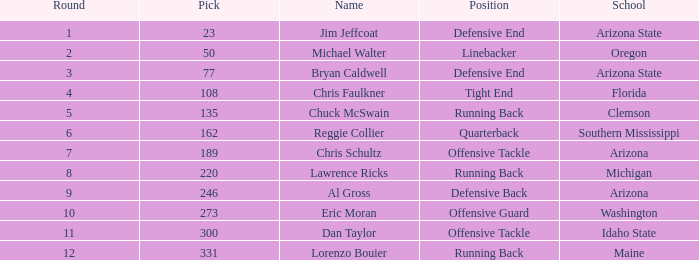What is the count of the pick for round 11? 300.0. 